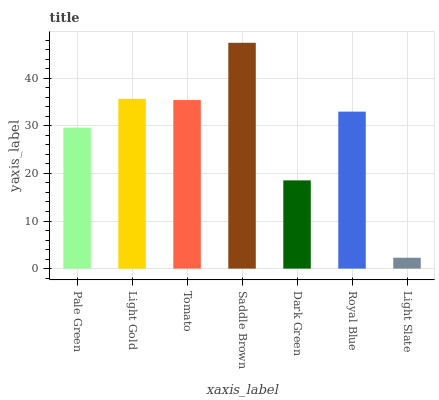Is Light Slate the minimum?
Answer yes or no. Yes. Is Saddle Brown the maximum?
Answer yes or no. Yes. Is Light Gold the minimum?
Answer yes or no. No. Is Light Gold the maximum?
Answer yes or no. No. Is Light Gold greater than Pale Green?
Answer yes or no. Yes. Is Pale Green less than Light Gold?
Answer yes or no. Yes. Is Pale Green greater than Light Gold?
Answer yes or no. No. Is Light Gold less than Pale Green?
Answer yes or no. No. Is Royal Blue the high median?
Answer yes or no. Yes. Is Royal Blue the low median?
Answer yes or no. Yes. Is Pale Green the high median?
Answer yes or no. No. Is Light Slate the low median?
Answer yes or no. No. 